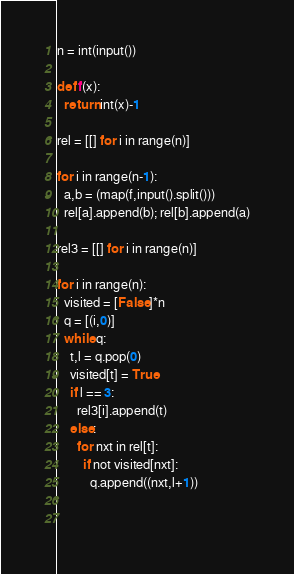<code> <loc_0><loc_0><loc_500><loc_500><_Python_>n = int(input())

def f(x):
  return int(x)-1

rel = [[] for i in range(n)]

for i in range(n-1):
  a,b = (map(f,input().split()))
  rel[a].append(b); rel[b].append(a)

rel3 = [[] for i in range(n)]

for i in range(n):
  visited = [False]*n
  q = [(i,0)]
  while q:
    t,l = q.pop(0)
    visited[t] = True
    if l == 3:
      rel3[i].append(t)
    else:
      for nxt in rel[t]:
        if not visited[nxt]:
          q.append((nxt,l+1))
    
  

</code> 